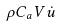<formula> <loc_0><loc_0><loc_500><loc_500>\rho C _ { a } V \dot { u }</formula> 